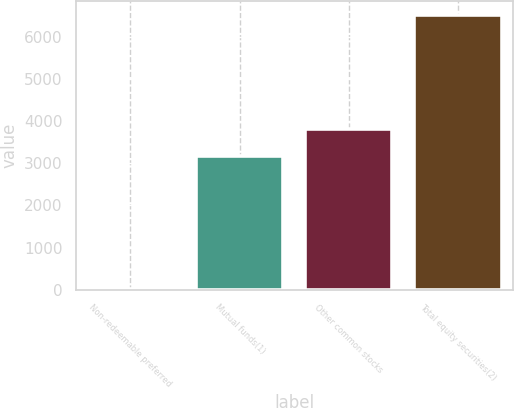Convert chart to OTSL. <chart><loc_0><loc_0><loc_500><loc_500><bar_chart><fcel>Non-redeemable preferred<fcel>Mutual funds(1)<fcel>Other common stocks<fcel>Total equity securities(2)<nl><fcel>21<fcel>3175<fcel>3826.6<fcel>6537<nl></chart> 